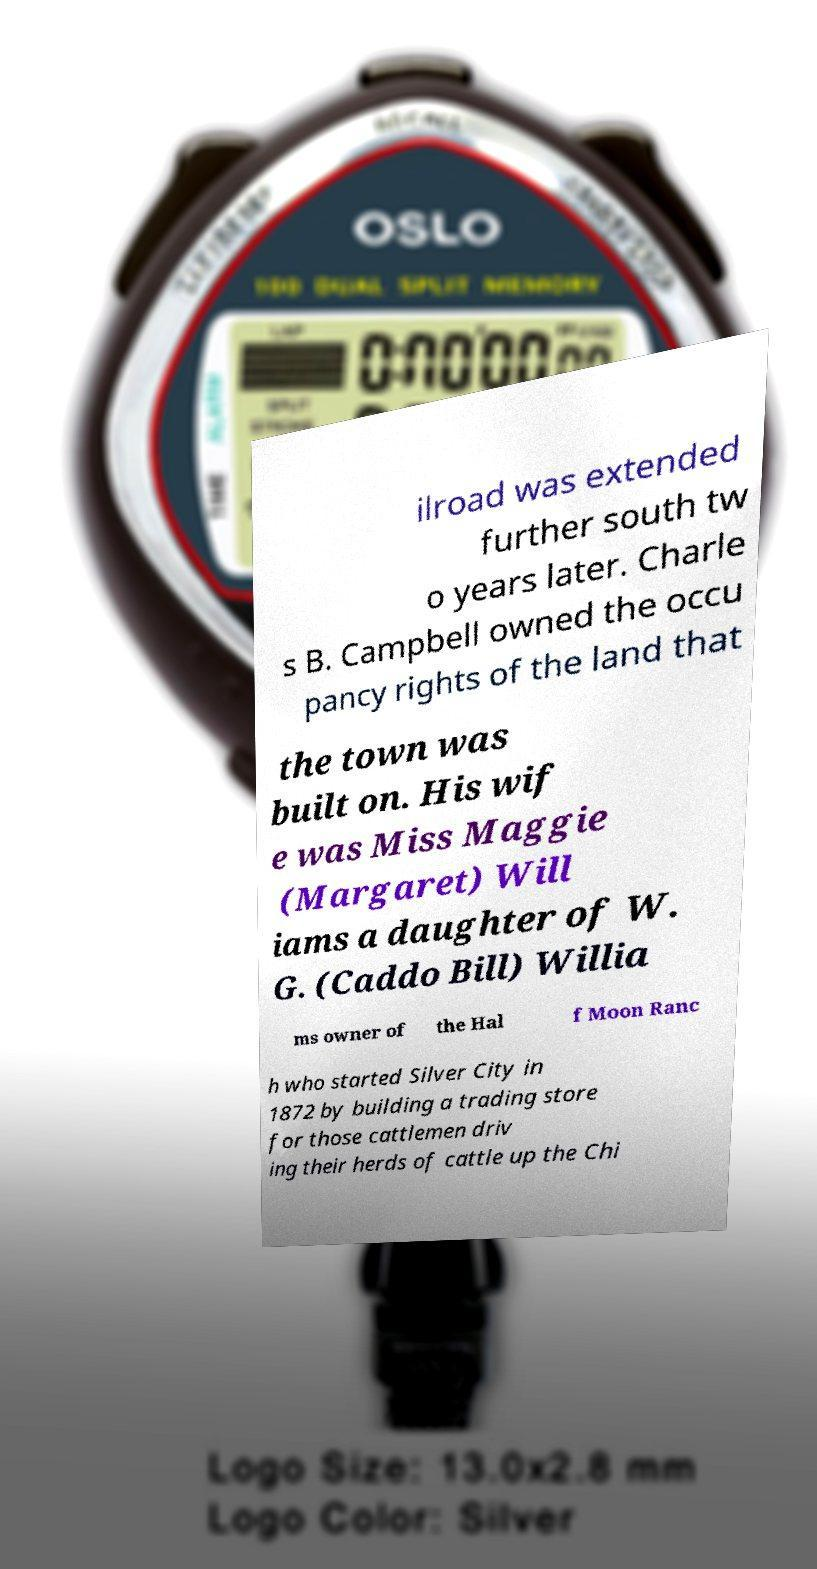Please read and relay the text visible in this image. What does it say? ilroad was extended further south tw o years later. Charle s B. Campbell owned the occu pancy rights of the land that the town was built on. His wif e was Miss Maggie (Margaret) Will iams a daughter of W. G. (Caddo Bill) Willia ms owner of the Hal f Moon Ranc h who started Silver City in 1872 by building a trading store for those cattlemen driv ing their herds of cattle up the Chi 